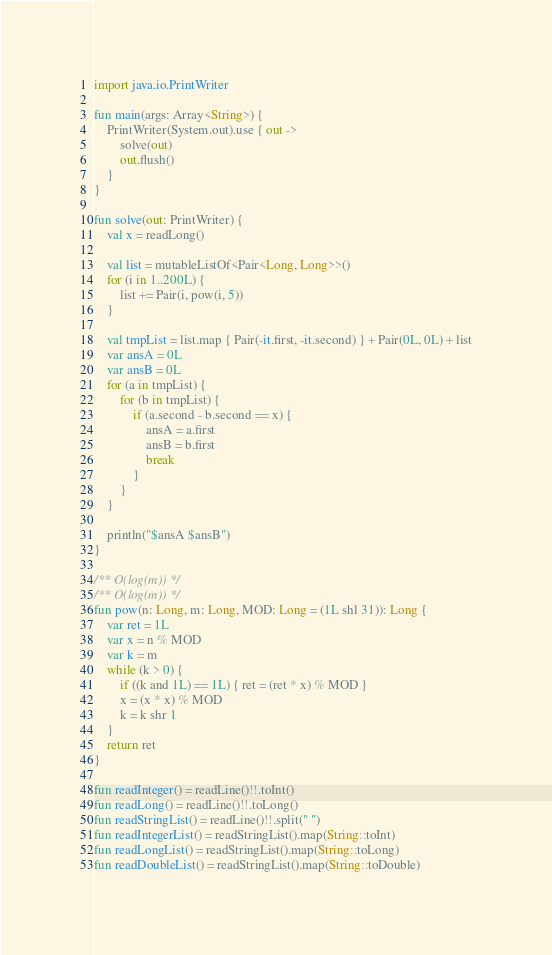Convert code to text. <code><loc_0><loc_0><loc_500><loc_500><_Kotlin_>import java.io.PrintWriter

fun main(args: Array<String>) {
    PrintWriter(System.out).use { out ->
        solve(out)
        out.flush()
    }
}

fun solve(out: PrintWriter) {
    val x = readLong()

    val list = mutableListOf<Pair<Long, Long>>()
    for (i in 1..200L) {
        list += Pair(i, pow(i, 5))
    }

    val tmpList = list.map { Pair(-it.first, -it.second) } + Pair(0L, 0L) + list
    var ansA = 0L
    var ansB = 0L
    for (a in tmpList) {
        for (b in tmpList) {
            if (a.second - b.second == x) {
                ansA = a.first
                ansB = b.first
                break
            }
        }
    }

    println("$ansA $ansB")
}

/** O(log(m)) */
/** O(log(m)) */
fun pow(n: Long, m: Long, MOD: Long = (1L shl 31)): Long {
    var ret = 1L
    var x = n % MOD
    var k = m
    while (k > 0) {
        if ((k and 1L) == 1L) { ret = (ret * x) % MOD }
        x = (x * x) % MOD
        k = k shr 1
    }
    return ret
}

fun readInteger() = readLine()!!.toInt()
fun readLong() = readLine()!!.toLong()
fun readStringList() = readLine()!!.split(" ")
fun readIntegerList() = readStringList().map(String::toInt)
fun readLongList() = readStringList().map(String::toLong)
fun readDoubleList() = readStringList().map(String::toDouble)</code> 